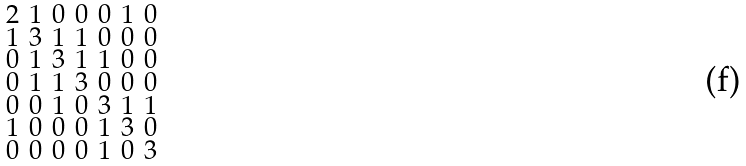<formula> <loc_0><loc_0><loc_500><loc_500>\begin{smallmatrix} 2 & 1 & 0 & 0 & 0 & 1 & 0 \\ 1 & 3 & 1 & 1 & 0 & 0 & 0 \\ 0 & 1 & 3 & 1 & 1 & 0 & 0 \\ 0 & 1 & 1 & 3 & 0 & 0 & 0 \\ 0 & 0 & 1 & 0 & 3 & 1 & 1 \\ 1 & 0 & 0 & 0 & 1 & 3 & 0 \\ 0 & 0 & 0 & 0 & 1 & 0 & 3 \end{smallmatrix}</formula> 